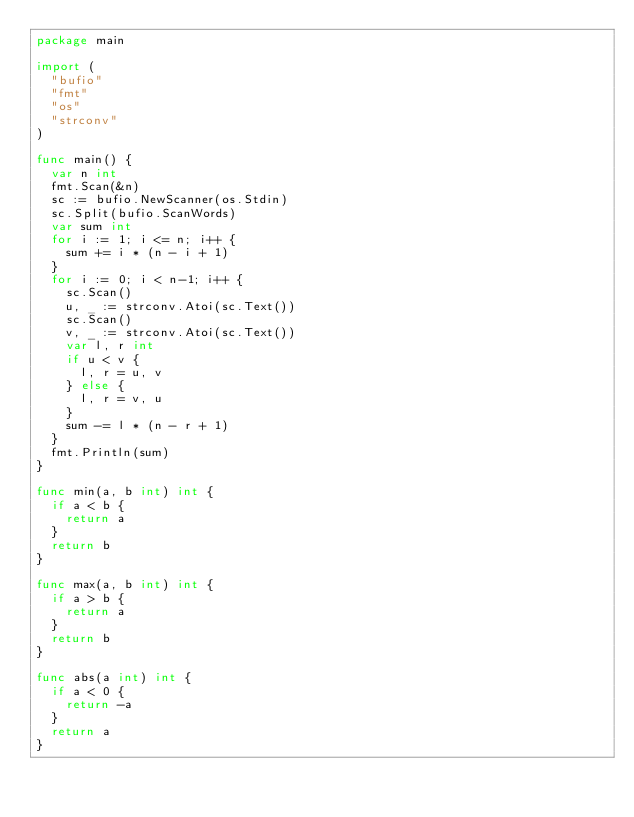<code> <loc_0><loc_0><loc_500><loc_500><_Go_>package main

import (
	"bufio"
	"fmt"
	"os"
	"strconv"
)

func main() {
	var n int
	fmt.Scan(&n)
	sc := bufio.NewScanner(os.Stdin)
	sc.Split(bufio.ScanWords)
	var sum int
	for i := 1; i <= n; i++ {
		sum += i * (n - i + 1)
	}
	for i := 0; i < n-1; i++ {
		sc.Scan()
		u, _ := strconv.Atoi(sc.Text())
		sc.Scan()
		v, _ := strconv.Atoi(sc.Text())
		var l, r int
		if u < v {
			l, r = u, v
		} else {
			l, r = v, u
		}
		sum -= l * (n - r + 1)
	}
	fmt.Println(sum)
}

func min(a, b int) int {
	if a < b {
		return a
	}
	return b
}

func max(a, b int) int {
	if a > b {
		return a
	}
	return b
}

func abs(a int) int {
	if a < 0 {
		return -a
	}
	return a
}
</code> 